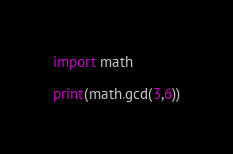Convert code to text. <code><loc_0><loc_0><loc_500><loc_500><_Python_>import math

print(math.gcd(3,6))</code> 